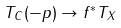Convert formula to latex. <formula><loc_0><loc_0><loc_500><loc_500>T _ { C } ( - p ) \to f ^ { * } T _ { X }</formula> 